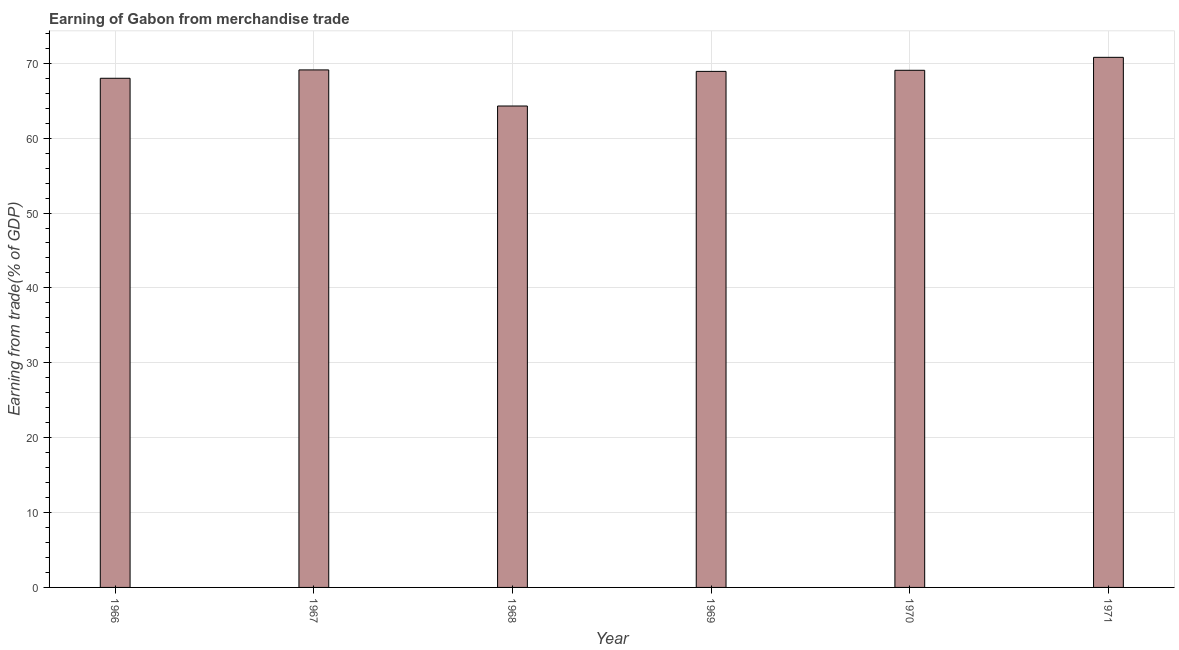Does the graph contain any zero values?
Your answer should be very brief. No. What is the title of the graph?
Make the answer very short. Earning of Gabon from merchandise trade. What is the label or title of the Y-axis?
Provide a succinct answer. Earning from trade(% of GDP). What is the earning from merchandise trade in 1967?
Give a very brief answer. 69.11. Across all years, what is the maximum earning from merchandise trade?
Provide a short and direct response. 70.79. Across all years, what is the minimum earning from merchandise trade?
Provide a short and direct response. 64.29. In which year was the earning from merchandise trade maximum?
Make the answer very short. 1971. In which year was the earning from merchandise trade minimum?
Offer a very short reply. 1968. What is the sum of the earning from merchandise trade?
Your response must be concise. 410.18. What is the difference between the earning from merchandise trade in 1966 and 1968?
Offer a very short reply. 3.7. What is the average earning from merchandise trade per year?
Your response must be concise. 68.36. What is the median earning from merchandise trade?
Provide a succinct answer. 68.99. In how many years, is the earning from merchandise trade greater than 48 %?
Your response must be concise. 6. Do a majority of the years between 1966 and 1969 (inclusive) have earning from merchandise trade greater than 48 %?
Offer a very short reply. Yes. What is the ratio of the earning from merchandise trade in 1967 to that in 1970?
Offer a very short reply. 1. Is the difference between the earning from merchandise trade in 1967 and 1968 greater than the difference between any two years?
Give a very brief answer. No. What is the difference between the highest and the second highest earning from merchandise trade?
Provide a succinct answer. 1.68. In how many years, is the earning from merchandise trade greater than the average earning from merchandise trade taken over all years?
Your answer should be very brief. 4. How many years are there in the graph?
Give a very brief answer. 6. What is the difference between two consecutive major ticks on the Y-axis?
Your answer should be very brief. 10. Are the values on the major ticks of Y-axis written in scientific E-notation?
Your answer should be compact. No. What is the Earning from trade(% of GDP) in 1966?
Your response must be concise. 68. What is the Earning from trade(% of GDP) in 1967?
Offer a terse response. 69.11. What is the Earning from trade(% of GDP) of 1968?
Your response must be concise. 64.29. What is the Earning from trade(% of GDP) of 1969?
Give a very brief answer. 68.92. What is the Earning from trade(% of GDP) of 1970?
Make the answer very short. 69.06. What is the Earning from trade(% of GDP) of 1971?
Give a very brief answer. 70.79. What is the difference between the Earning from trade(% of GDP) in 1966 and 1967?
Give a very brief answer. -1.12. What is the difference between the Earning from trade(% of GDP) in 1966 and 1968?
Ensure brevity in your answer.  3.7. What is the difference between the Earning from trade(% of GDP) in 1966 and 1969?
Keep it short and to the point. -0.92. What is the difference between the Earning from trade(% of GDP) in 1966 and 1970?
Offer a terse response. -1.07. What is the difference between the Earning from trade(% of GDP) in 1966 and 1971?
Make the answer very short. -2.8. What is the difference between the Earning from trade(% of GDP) in 1967 and 1968?
Your answer should be compact. 4.82. What is the difference between the Earning from trade(% of GDP) in 1967 and 1969?
Give a very brief answer. 0.2. What is the difference between the Earning from trade(% of GDP) in 1967 and 1970?
Offer a terse response. 0.05. What is the difference between the Earning from trade(% of GDP) in 1967 and 1971?
Provide a succinct answer. -1.68. What is the difference between the Earning from trade(% of GDP) in 1968 and 1969?
Your response must be concise. -4.62. What is the difference between the Earning from trade(% of GDP) in 1968 and 1970?
Your response must be concise. -4.77. What is the difference between the Earning from trade(% of GDP) in 1968 and 1971?
Ensure brevity in your answer.  -6.5. What is the difference between the Earning from trade(% of GDP) in 1969 and 1970?
Your answer should be compact. -0.15. What is the difference between the Earning from trade(% of GDP) in 1969 and 1971?
Ensure brevity in your answer.  -1.88. What is the difference between the Earning from trade(% of GDP) in 1970 and 1971?
Your answer should be very brief. -1.73. What is the ratio of the Earning from trade(% of GDP) in 1966 to that in 1967?
Your answer should be compact. 0.98. What is the ratio of the Earning from trade(% of GDP) in 1966 to that in 1968?
Provide a succinct answer. 1.06. What is the ratio of the Earning from trade(% of GDP) in 1966 to that in 1969?
Your answer should be very brief. 0.99. What is the ratio of the Earning from trade(% of GDP) in 1966 to that in 1970?
Keep it short and to the point. 0.98. What is the ratio of the Earning from trade(% of GDP) in 1966 to that in 1971?
Offer a very short reply. 0.96. What is the ratio of the Earning from trade(% of GDP) in 1967 to that in 1968?
Your answer should be very brief. 1.07. What is the ratio of the Earning from trade(% of GDP) in 1967 to that in 1969?
Your answer should be compact. 1. What is the ratio of the Earning from trade(% of GDP) in 1968 to that in 1969?
Your response must be concise. 0.93. What is the ratio of the Earning from trade(% of GDP) in 1968 to that in 1970?
Make the answer very short. 0.93. What is the ratio of the Earning from trade(% of GDP) in 1968 to that in 1971?
Offer a very short reply. 0.91. What is the ratio of the Earning from trade(% of GDP) in 1969 to that in 1971?
Offer a terse response. 0.97. What is the ratio of the Earning from trade(% of GDP) in 1970 to that in 1971?
Offer a very short reply. 0.98. 